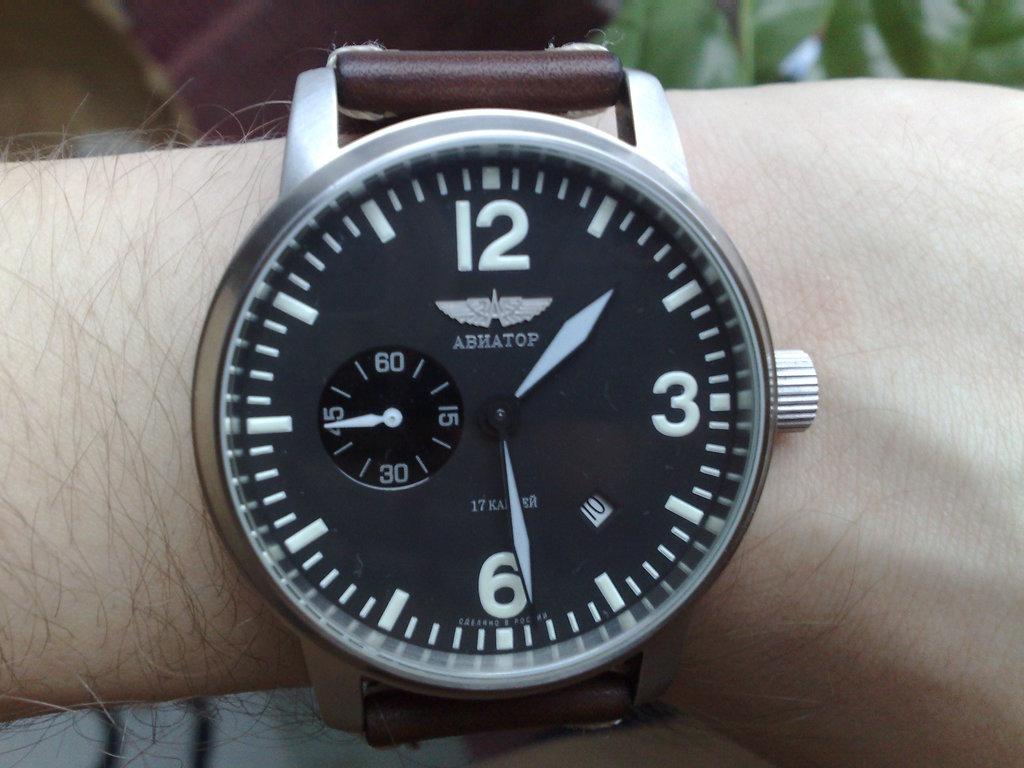What brand of watch?
Ensure brevity in your answer.  Abhatop. What time is shown on the watch?
Offer a terse response. 1:29. 